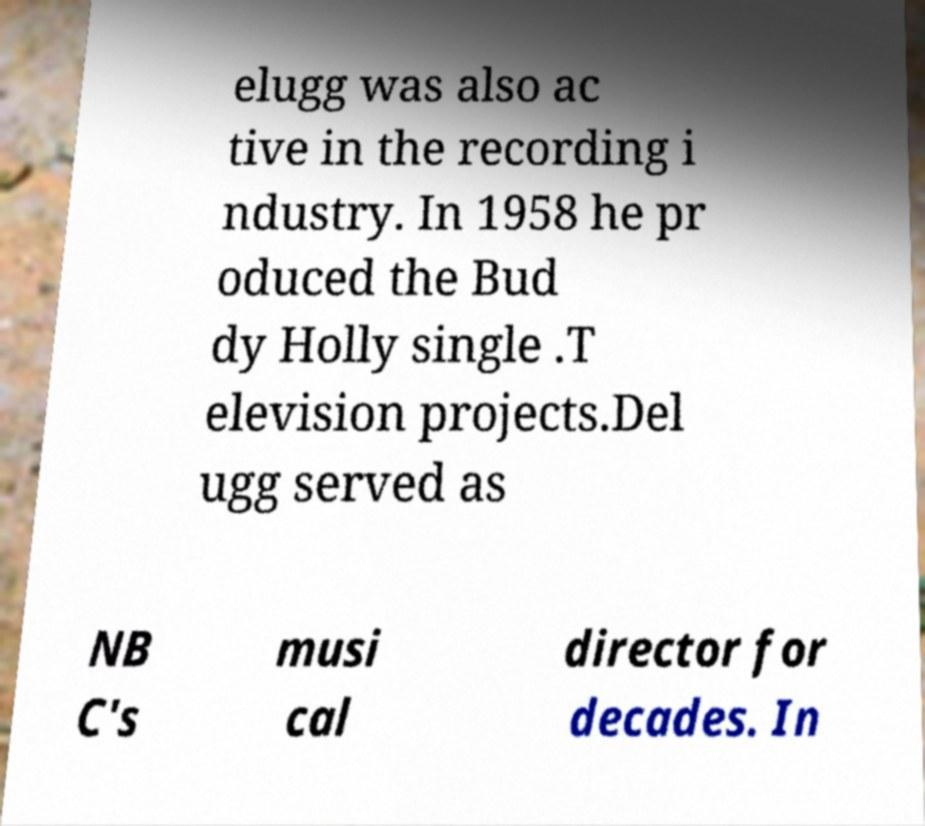Please identify and transcribe the text found in this image. elugg was also ac tive in the recording i ndustry. In 1958 he pr oduced the Bud dy Holly single .T elevision projects.Del ugg served as NB C's musi cal director for decades. In 